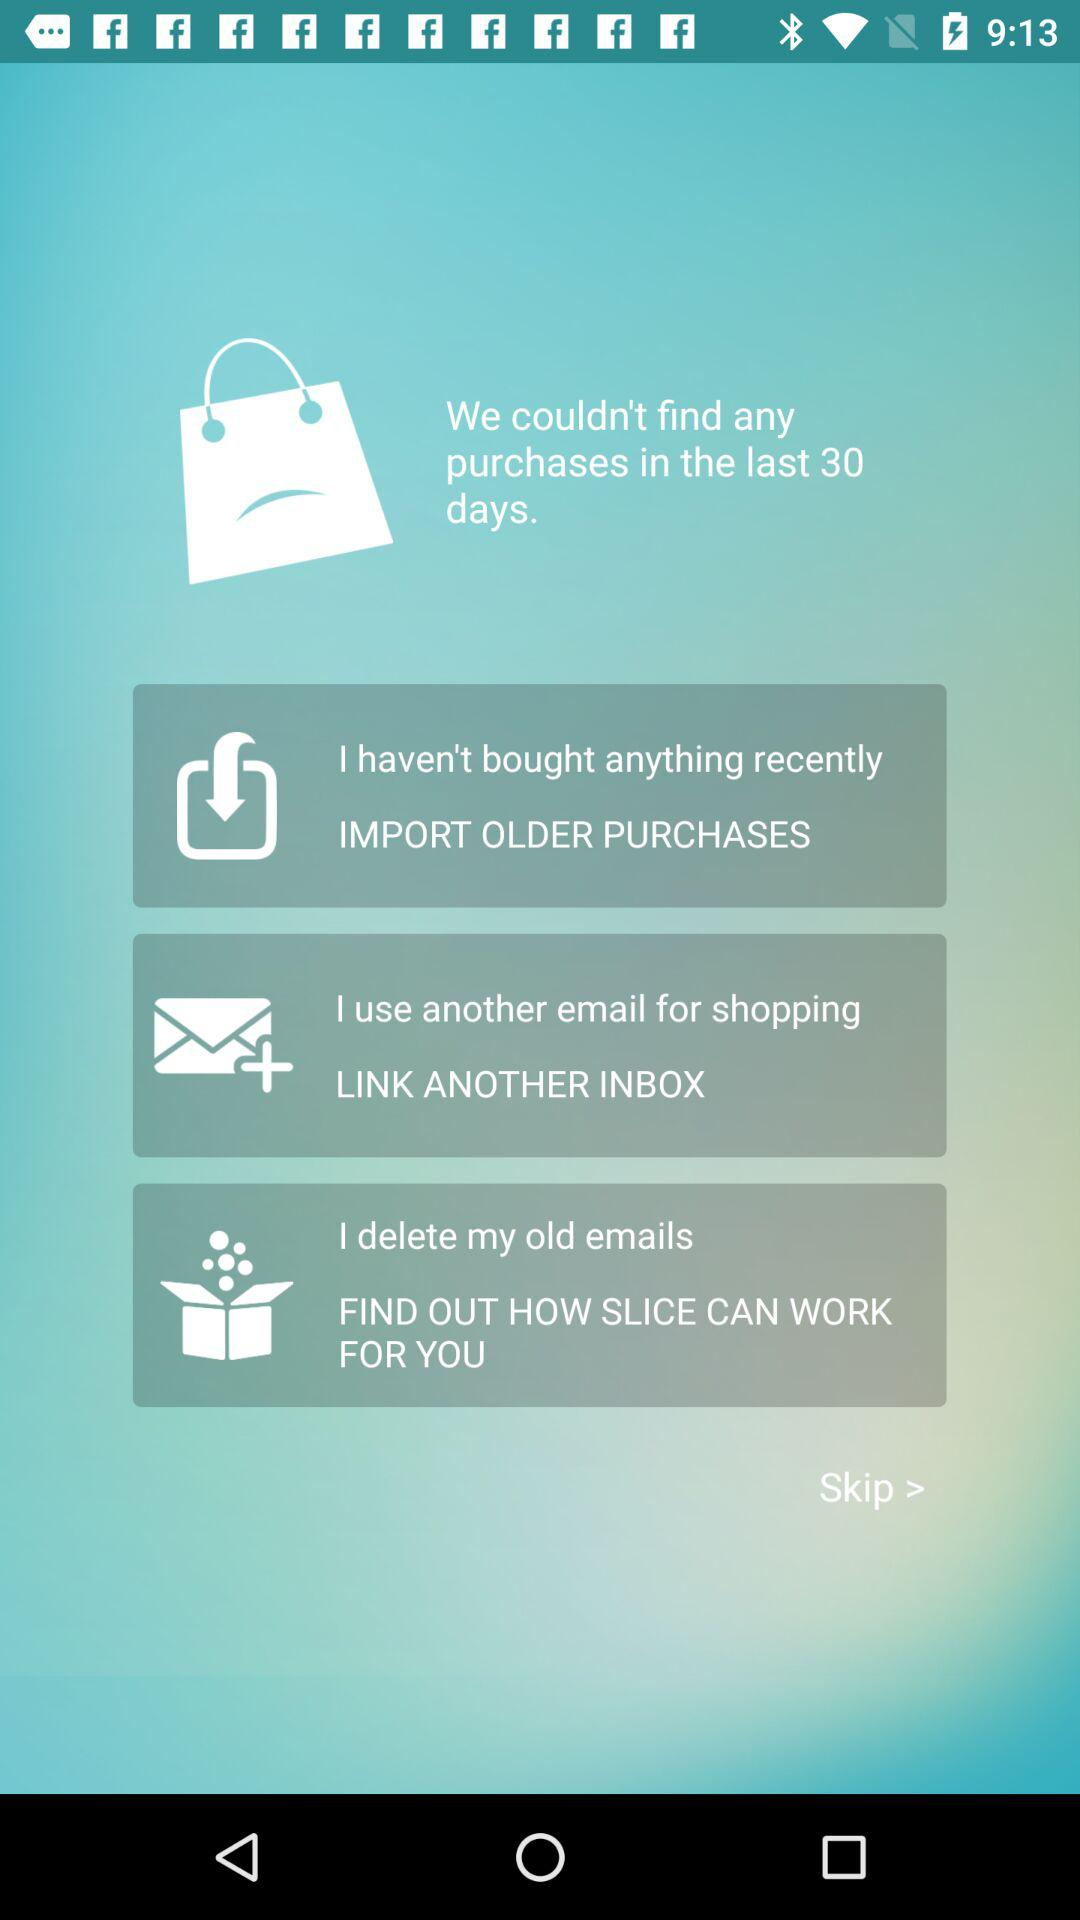How many options are there to resolve the issue?
Answer the question using a single word or phrase. 3 